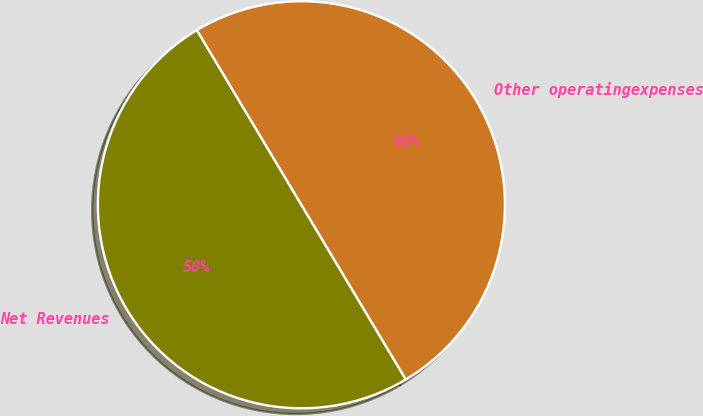Convert chart to OTSL. <chart><loc_0><loc_0><loc_500><loc_500><pie_chart><fcel>Net Revenues<fcel>Other operatingexpenses<nl><fcel>50.0%<fcel>50.0%<nl></chart> 